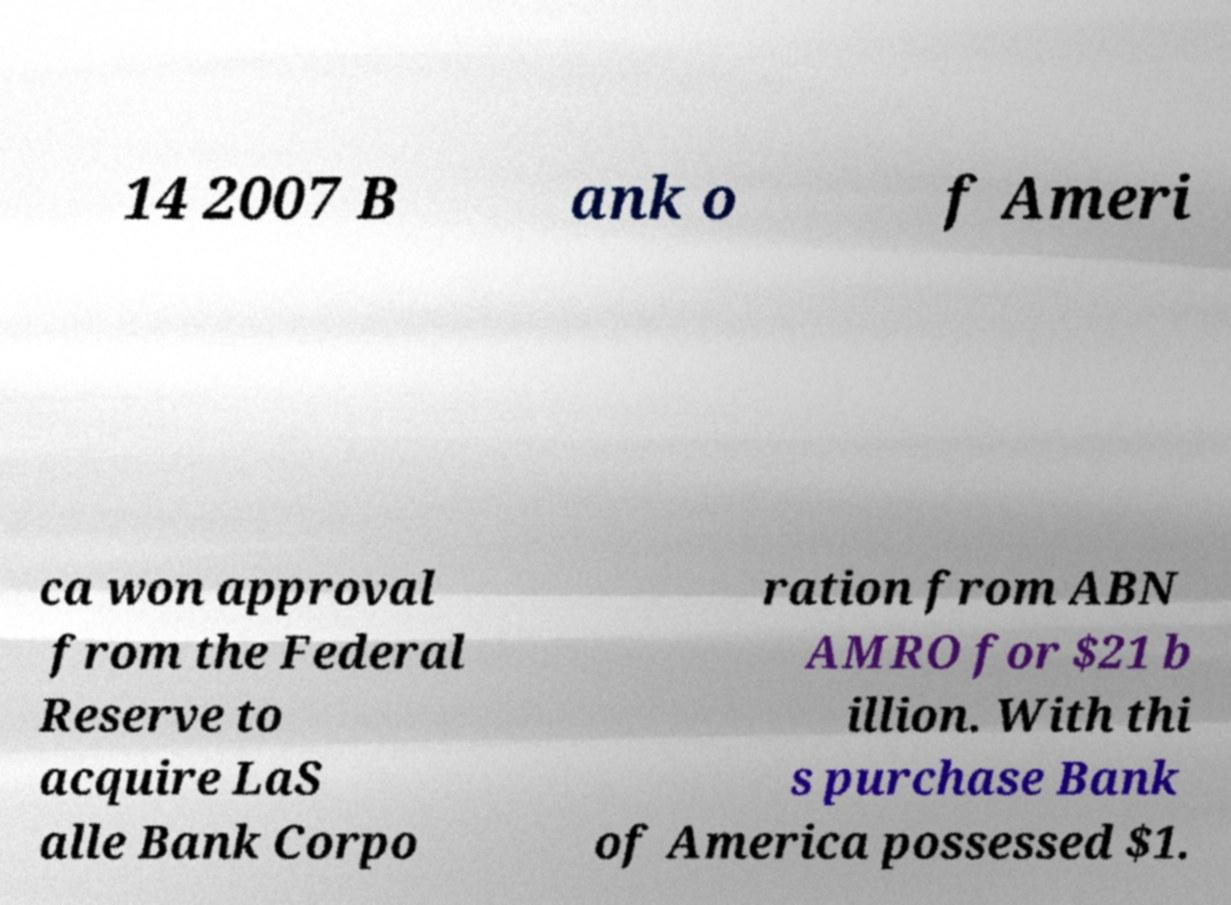Can you accurately transcribe the text from the provided image for me? 14 2007 B ank o f Ameri ca won approval from the Federal Reserve to acquire LaS alle Bank Corpo ration from ABN AMRO for $21 b illion. With thi s purchase Bank of America possessed $1. 